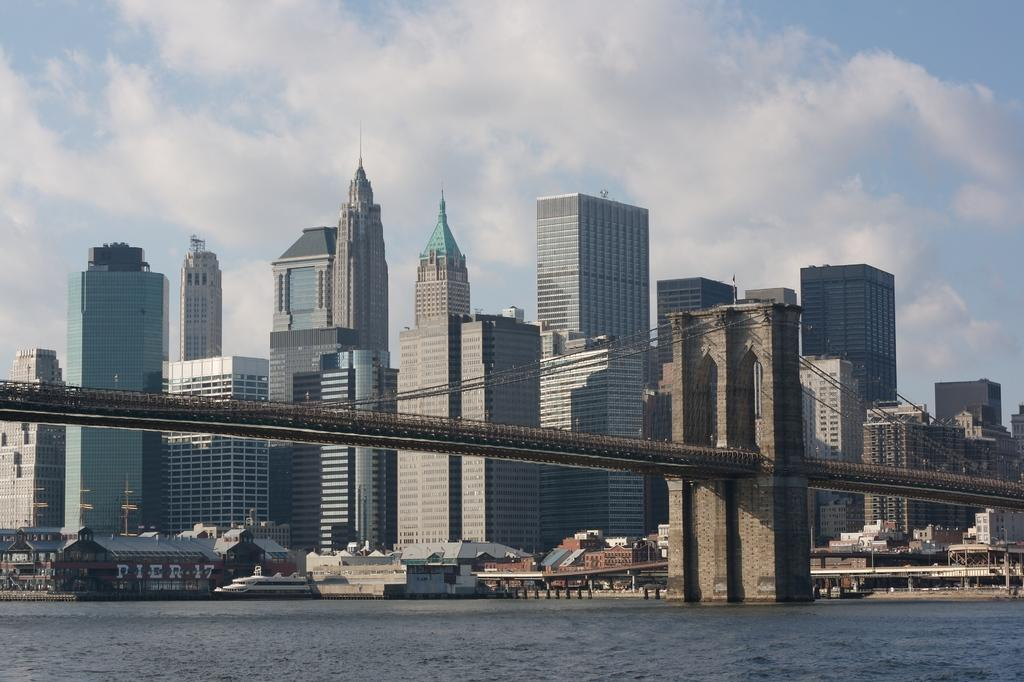What is in the foreground of the image? There is a water body in the foreground of the image. What structure can be seen in the image? There is a bridge in the image. What type of structures are visible in the background of the image? There are buildings in the background of the image. How would you describe the sky in the image? The sky is cloudy in the image. Where is the rake being used in the image? There is no rake present in the image. What thought is being expressed by the water body in the image? The water body is an inanimate object and cannot express thoughts. 